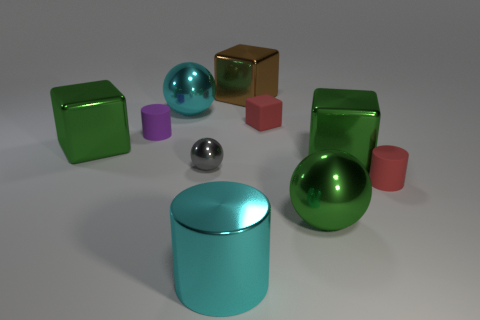Subtract all spheres. How many objects are left? 7 Add 9 big cyan metallic cylinders. How many big cyan metallic cylinders are left? 10 Add 3 large brown things. How many large brown things exist? 4 Subtract 1 red blocks. How many objects are left? 9 Subtract all cyan shiny cylinders. Subtract all small yellow rubber cylinders. How many objects are left? 9 